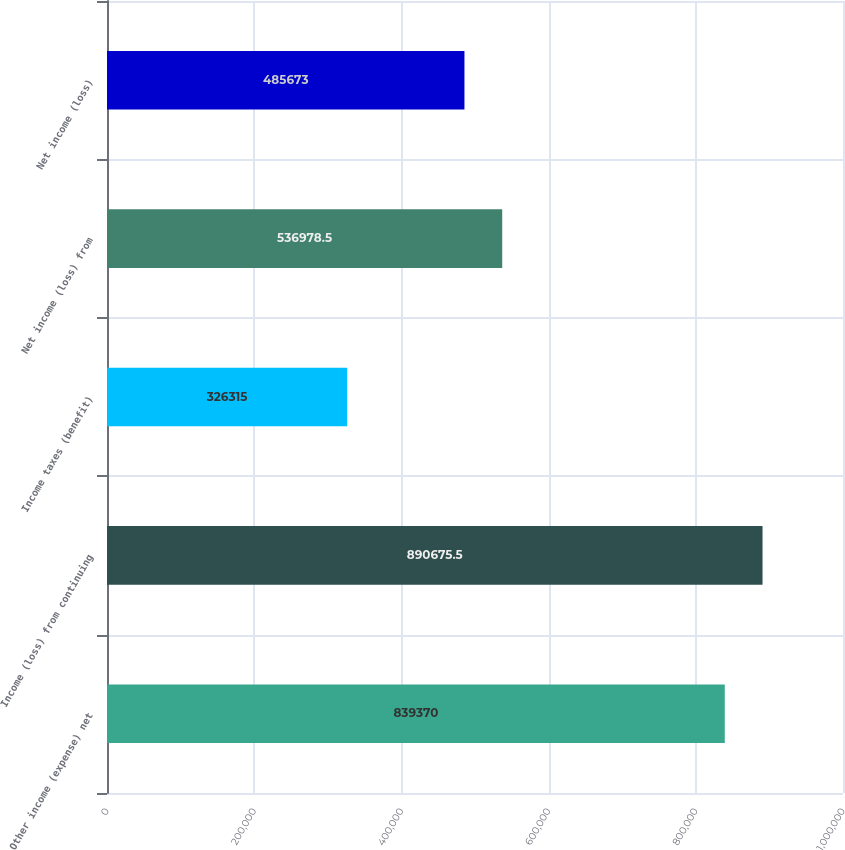Convert chart to OTSL. <chart><loc_0><loc_0><loc_500><loc_500><bar_chart><fcel>Other income (expense) net<fcel>Income (loss) from continuing<fcel>Income taxes (benefit)<fcel>Net income (loss) from<fcel>Net income (loss)<nl><fcel>839370<fcel>890676<fcel>326315<fcel>536978<fcel>485673<nl></chart> 